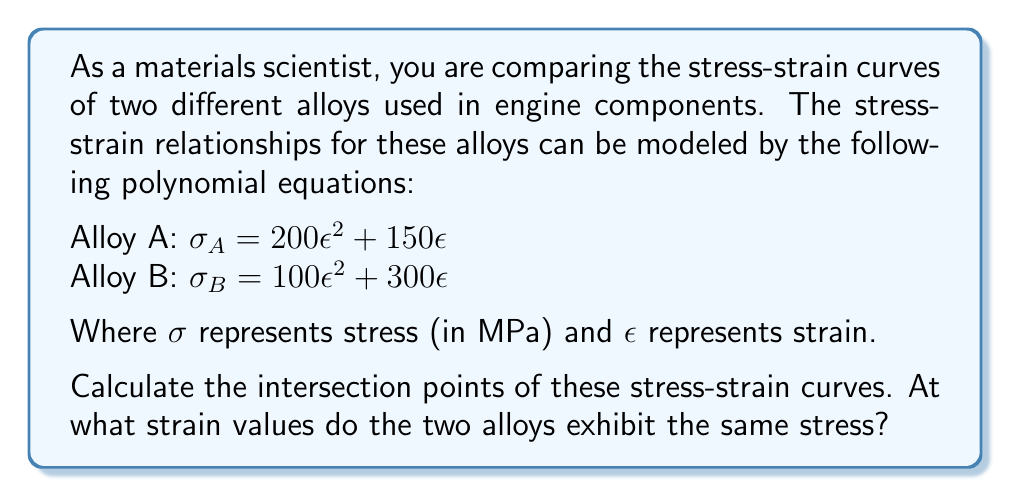Provide a solution to this math problem. To find the intersection points of the stress-strain curves, we need to set the equations equal to each other and solve for $\epsilon$:

$\sigma_A = \sigma_B$
$200\epsilon^2 + 150\epsilon = 100\epsilon^2 + 300\epsilon$

Rearranging the equation:
$100\epsilon^2 - 150\epsilon = 0$

Factoring out the common term:
$\epsilon(100\epsilon - 150) = 0$

Using the zero product property, we can split this into two equations:
$\epsilon = 0$ or $100\epsilon - 150 = 0$

Solving the second equation:
$100\epsilon = 150$
$\epsilon = 1.5$

Therefore, the strain values at which the two alloys exhibit the same stress are $\epsilon = 0$ and $\epsilon = 1.5$.

To verify, we can substitute these values back into either stress equation:

For $\epsilon = 0$:
$\sigma_A = \sigma_B = 200(0)^2 + 150(0) = 0$ MPa

For $\epsilon = 1.5$:
$\sigma_A = \sigma_B = 200(1.5)^2 + 150(1.5) = 675$ MPa

These calculations confirm that the stress values are indeed equal at these strain points.
Answer: The stress-strain curves intersect at two points: $\epsilon = 0$ and $\epsilon = 1.5$. 